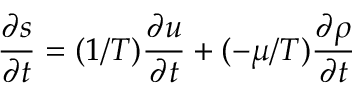<formula> <loc_0><loc_0><loc_500><loc_500>{ \frac { \partial s } { \partial t } } = ( 1 / T ) { \frac { \partial u } { \partial t } } + ( - \mu / T ) { \frac { \partial \rho } { \partial t } }</formula> 